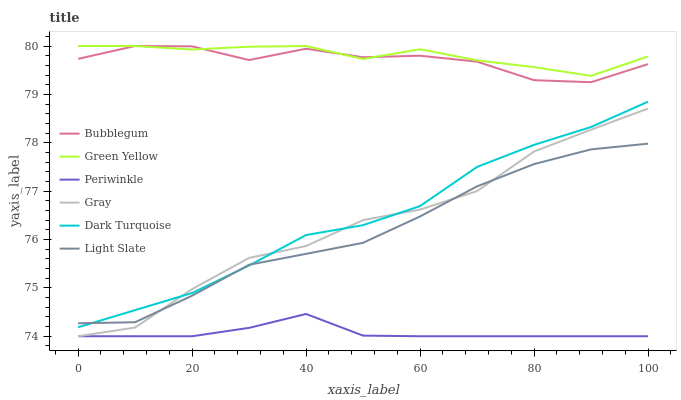Does Light Slate have the minimum area under the curve?
Answer yes or no. No. Does Light Slate have the maximum area under the curve?
Answer yes or no. No. Is Light Slate the smoothest?
Answer yes or no. No. Is Light Slate the roughest?
Answer yes or no. No. Does Light Slate have the lowest value?
Answer yes or no. No. Does Light Slate have the highest value?
Answer yes or no. No. Is Gray less than Green Yellow?
Answer yes or no. Yes. Is Green Yellow greater than Periwinkle?
Answer yes or no. Yes. Does Gray intersect Green Yellow?
Answer yes or no. No. 